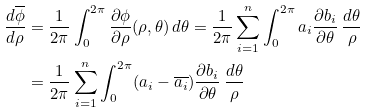Convert formula to latex. <formula><loc_0><loc_0><loc_500><loc_500>\frac { d { \overline { \phi } } } { d \rho } & = \frac { 1 } { 2 \pi } \int _ { 0 } ^ { 2 \pi } \frac { \partial \phi } { \partial \rho } ( \rho , \theta ) \, d \theta = \frac { 1 } { 2 \pi } \sum _ { i = 1 } ^ { n } \int _ { 0 } ^ { 2 \pi } a _ { i } \frac { \partial b _ { i } } { \partial \theta } \, \frac { d \theta } { \rho } \\ & = \frac { 1 } { 2 \pi } \sum _ { i = 1 } ^ { n } \int _ { 0 } ^ { 2 \pi } ( a _ { i } - \overline { a _ { i } } ) \frac { \partial b _ { i } } { \partial \theta } \, \frac { d \theta } { \rho }</formula> 